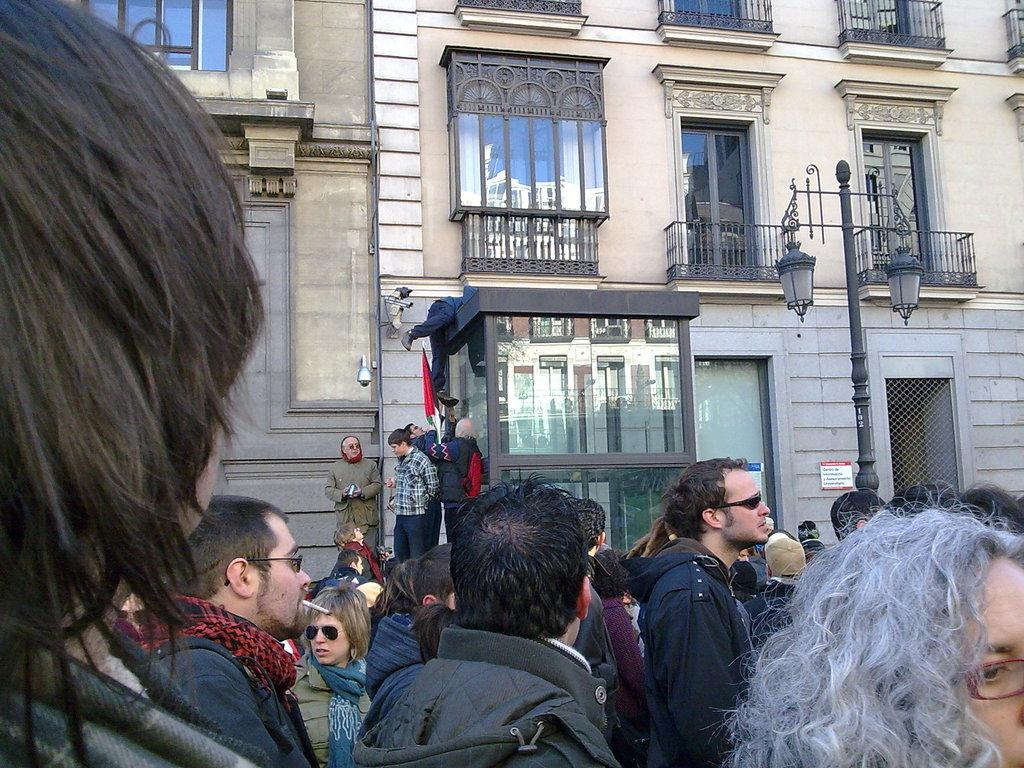What is happening with the group of people in the image? The people are walking on the street in the image. What can be seen in the background of the image? There is a brown color building with window glasses and a black color lamp post in the background. Can you describe the building in the background? The building in the background is brown in color and has window glasses. There is also a black color lamp post in the background. Is there a market where people are fighting over underwear in the image? No, there is no market or fighting over underwear in the image. The image shows a group of people walking on the street with a brown color building and a black color lamp post in the background. 